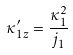<formula> <loc_0><loc_0><loc_500><loc_500>\kappa ^ { \prime } _ { 1 z } = \frac { \kappa _ { 1 } ^ { 2 } } { j _ { 1 } }</formula> 